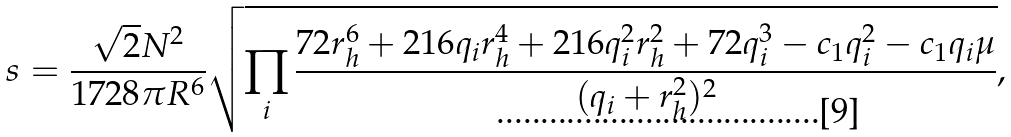Convert formula to latex. <formula><loc_0><loc_0><loc_500><loc_500>s = \frac { \sqrt { 2 } N ^ { 2 } } { 1 7 2 8 \pi R ^ { 6 } } \sqrt { \prod _ { i } \frac { 7 2 r _ { h } ^ { 6 } + 2 1 6 q _ { i } r _ { h } ^ { 4 } + 2 1 6 q _ { i } ^ { 2 } r _ { h } ^ { 2 } + 7 2 q _ { i } ^ { 3 } - c _ { 1 } q _ { i } ^ { 2 } - c _ { 1 } q _ { i } \mu } { ( q _ { i } + r _ { h } ^ { 2 } ) ^ { 2 } } } ,</formula> 